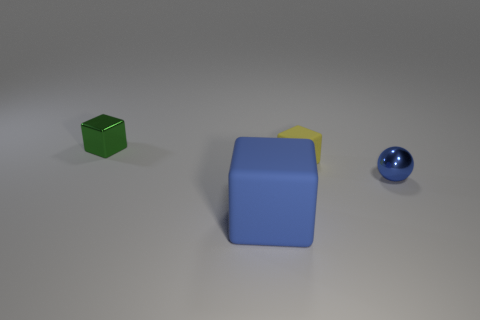Is there anything else that has the same size as the blue rubber thing?
Offer a terse response. No. There is a metal thing in front of the cube on the left side of the rubber block that is in front of the small blue shiny object; what is its size?
Provide a succinct answer. Small. What is the color of the large thing that is the same shape as the tiny green metal object?
Offer a very short reply. Blue. Are there more tiny yellow cubes to the right of the yellow block than objects?
Provide a short and direct response. No. There is a yellow rubber thing; does it have the same shape as the blue object that is in front of the blue sphere?
Provide a succinct answer. Yes. What is the size of the blue matte object that is the same shape as the tiny yellow object?
Keep it short and to the point. Large. Is the number of small yellow things greater than the number of large purple metal things?
Ensure brevity in your answer.  Yes. Do the tiny green thing and the small blue shiny object have the same shape?
Make the answer very short. No. What is the material of the big object in front of the thing that is right of the small yellow matte cube?
Offer a very short reply. Rubber. There is another thing that is the same color as the large matte thing; what is its material?
Offer a very short reply. Metal. 